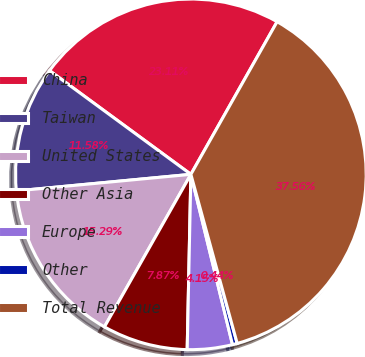<chart> <loc_0><loc_0><loc_500><loc_500><pie_chart><fcel>China<fcel>Taiwan<fcel>United States<fcel>Other Asia<fcel>Europe<fcel>Other<fcel>Total Revenue<nl><fcel>23.11%<fcel>11.58%<fcel>15.29%<fcel>7.87%<fcel>4.15%<fcel>0.44%<fcel>37.56%<nl></chart> 